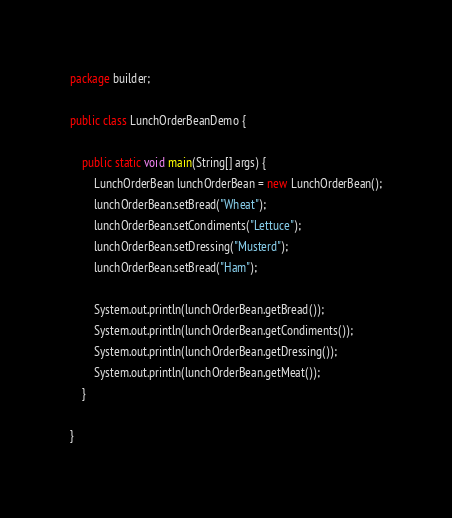<code> <loc_0><loc_0><loc_500><loc_500><_Java_>package builder;

public class LunchOrderBeanDemo {

    public static void main(String[] args) {
        LunchOrderBean lunchOrderBean = new LunchOrderBean();
        lunchOrderBean.setBread("Wheat");
        lunchOrderBean.setCondiments("Lettuce");
        lunchOrderBean.setDressing("Musterd");
        lunchOrderBean.setBread("Ham");

        System.out.println(lunchOrderBean.getBread());
        System.out.println(lunchOrderBean.getCondiments());
        System.out.println(lunchOrderBean.getDressing());
        System.out.println(lunchOrderBean.getMeat());
    }

}
</code> 